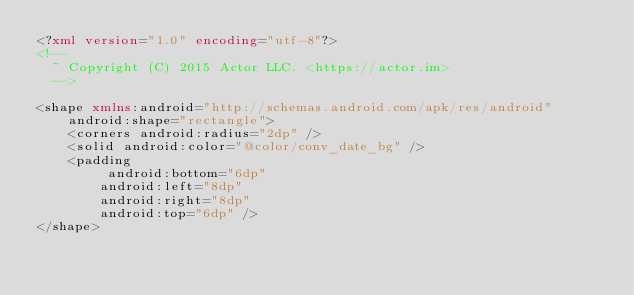<code> <loc_0><loc_0><loc_500><loc_500><_XML_><?xml version="1.0" encoding="utf-8"?>
<!--
  ~ Copyright (C) 2015 Actor LLC. <https://actor.im>
  -->

<shape xmlns:android="http://schemas.android.com/apk/res/android"
    android:shape="rectangle">
    <corners android:radius="2dp" />
    <solid android:color="@color/conv_date_bg" />
    <padding
         android:bottom="6dp"
        android:left="8dp"
        android:right="8dp"
        android:top="6dp" />
</shape></code> 